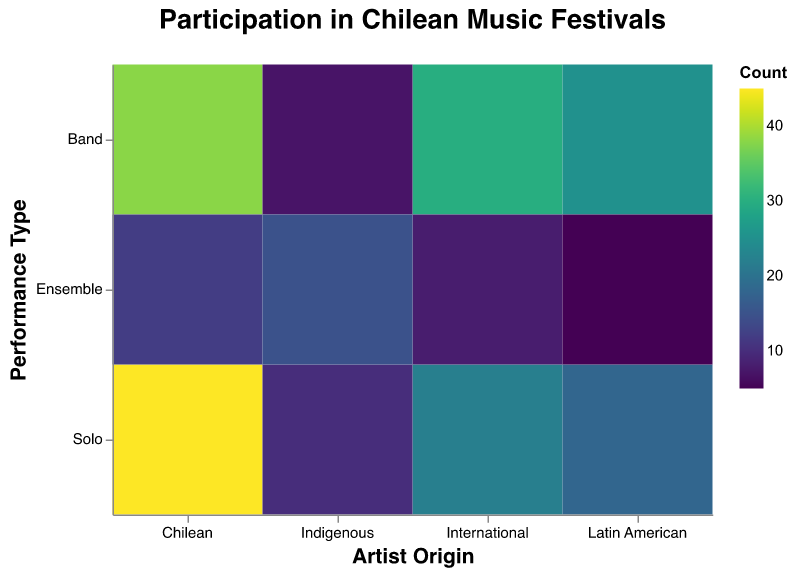How many bands from Chile participated in the festivals? The plot shows the counts of different performance types for each artist origin. For Chilean bands, the count is indicated at the intersection of "Chilean" (x-axis) and "Band" (y-axis). This value is 38.
Answer: 38 What is the total number of solo performances by Latin American artists? The plot shows the counts of performances. You need to locate the intersection of "Latin American" (x-axis) and "Solo" (y-axis), which shows a count of 18.
Answer: 18 Which artist origin had the highest number of ensemble performances? Looking at the plot, the rectangles' color intensity represents the count. By observing the Ensemble row across different artist origins, "Indigenous" stands out with the darkest color, indicating the highest count of 15.
Answer: Indigenous What is the difference in the number of solo performances between Chilean and International artists? Locate the solo performance counts for both Chilean (45) and International (22) artists, and calculate the difference: 45 - 22 = 23.
Answer: 23 Which performance type has the least participation from Indigenous artists? Observe the row labeled "Indigenous" across different performance types. The "Band" column has the lightest color, indicating the lowest count of 7.
Answer: Band What is the combined total of ensemble performances by International, Latin American, and Indigenous artists? Sum the counts of ensemble performances for International (8), Latin American (5), and Indigenous (15): 8 + 5 + 15 = 28.
Answer: 28 How many more total performances are there by Chilean artists compared to Latin American artists? First, sum the total performances by Chilean (45+38+12=95) and Latin American (18+25+5=48) artists, then calculate the difference: 95 - 48 = 47.
Answer: 47 Which artist origin has the most diverse performance type distribution? The plot shows the counts for different performance types. Chilean artists have the highest counts in all performance types, suggesting a more diverse distribution.
Answer: Chilean What is the average number of performances per performance type for all artist origins? First, sum the total performances across all categories (45+38+12+22+30+8+18+25+5+10+7+15=235). There are 12 categories in total. Divide the sum by 12: 235 / 12 = 19.58.
Answer: 19.58 